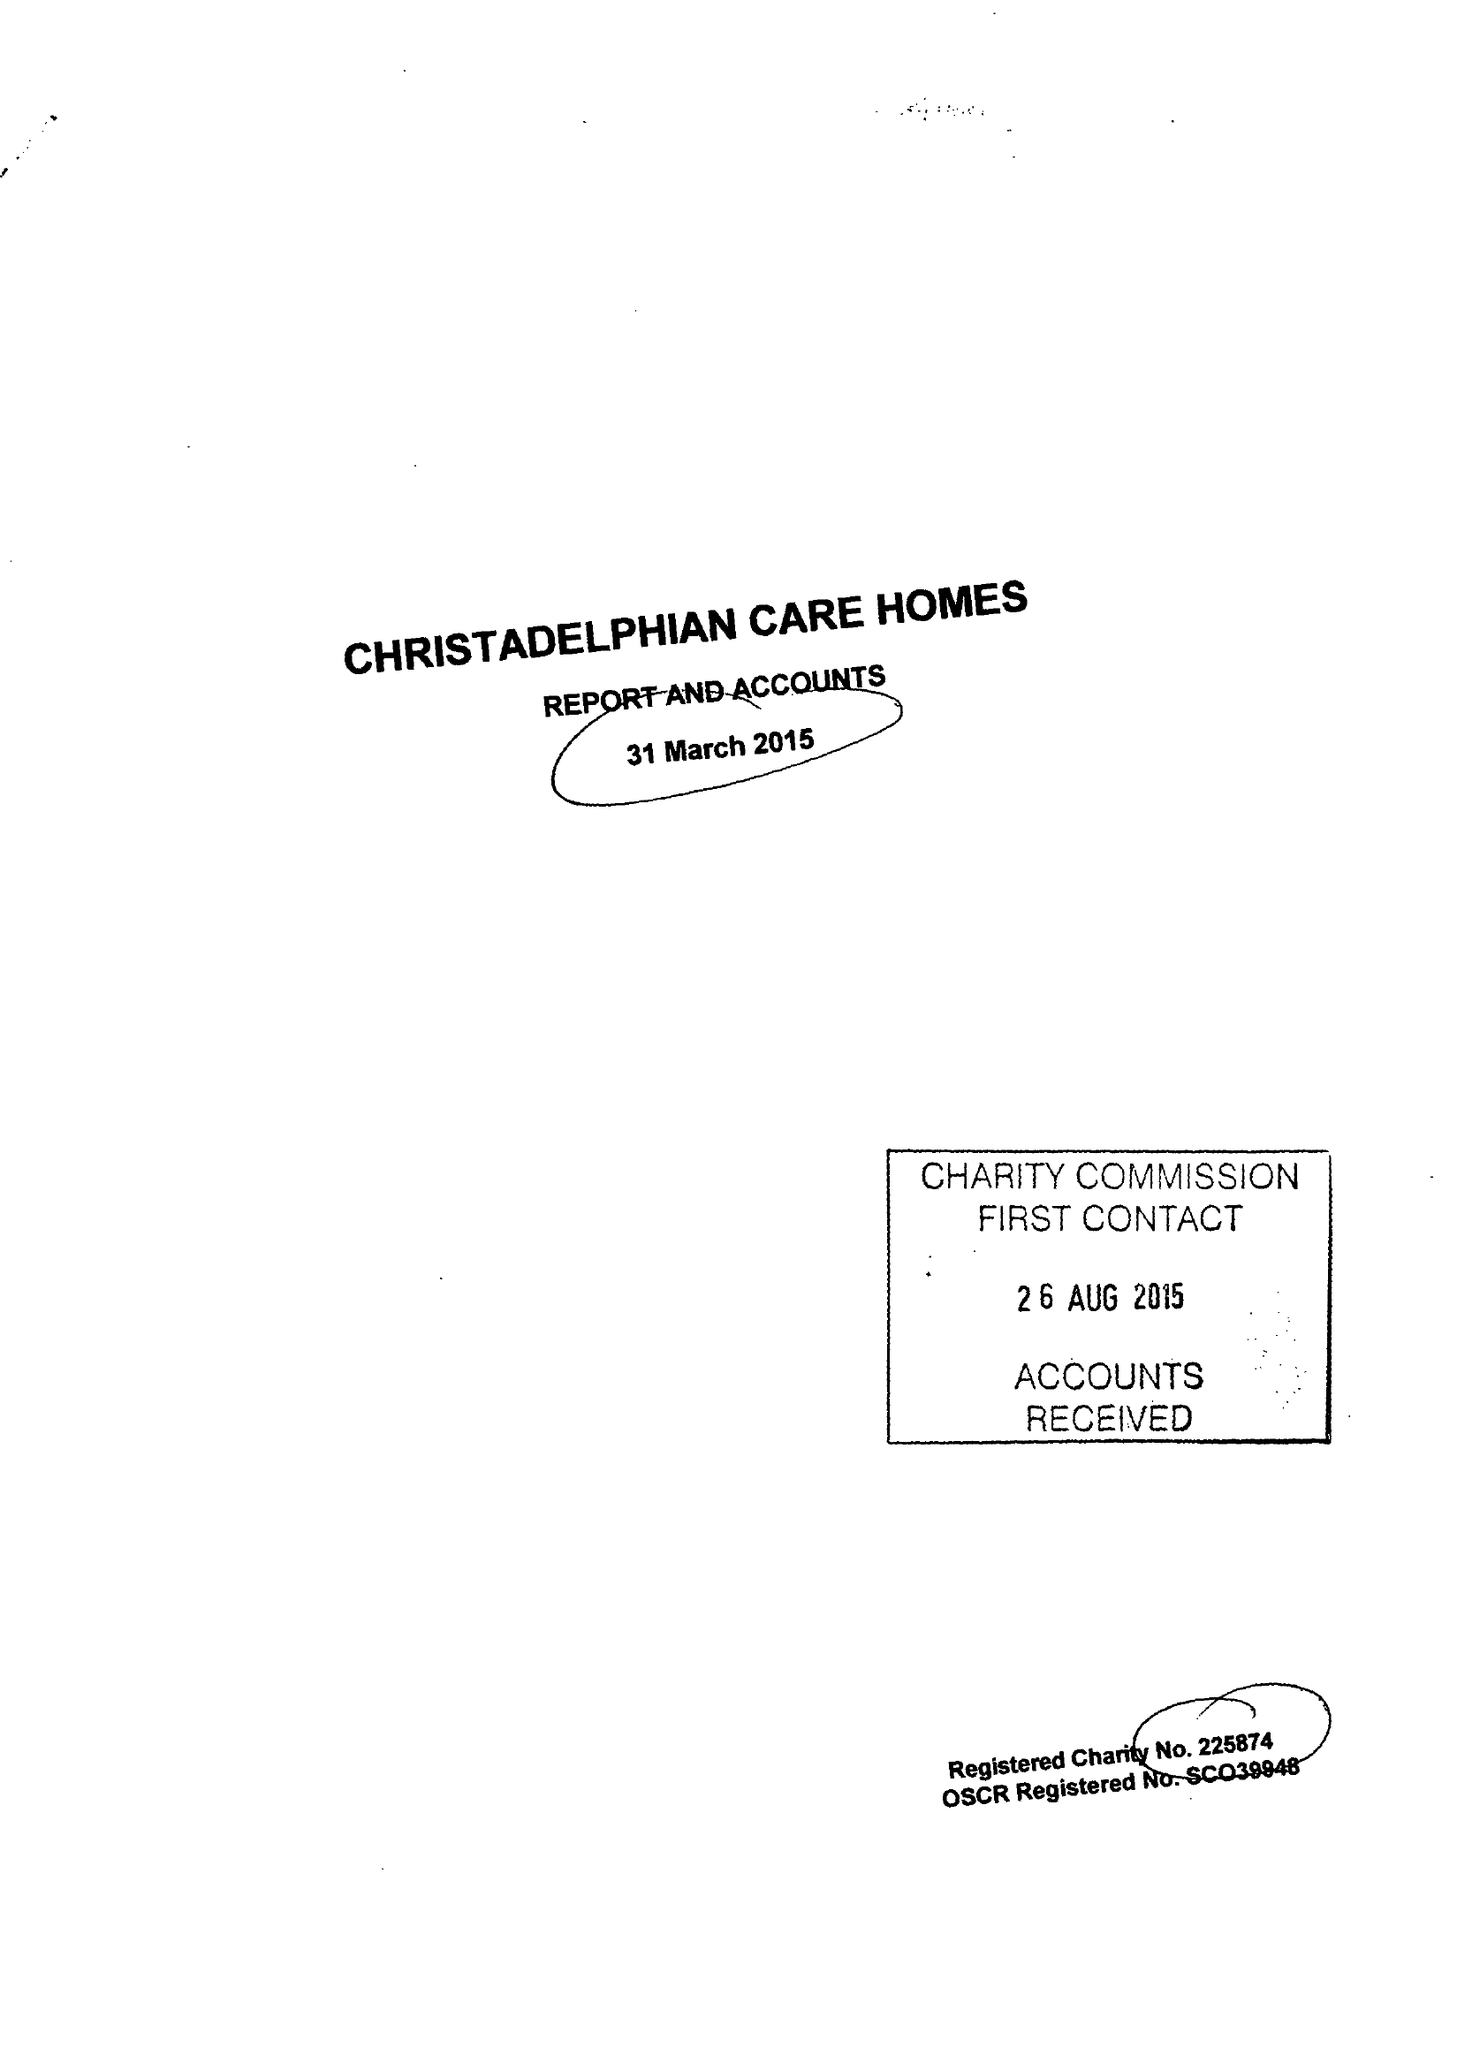What is the value for the address__postcode?
Answer the question using a single word or phrase. B27 6AD 